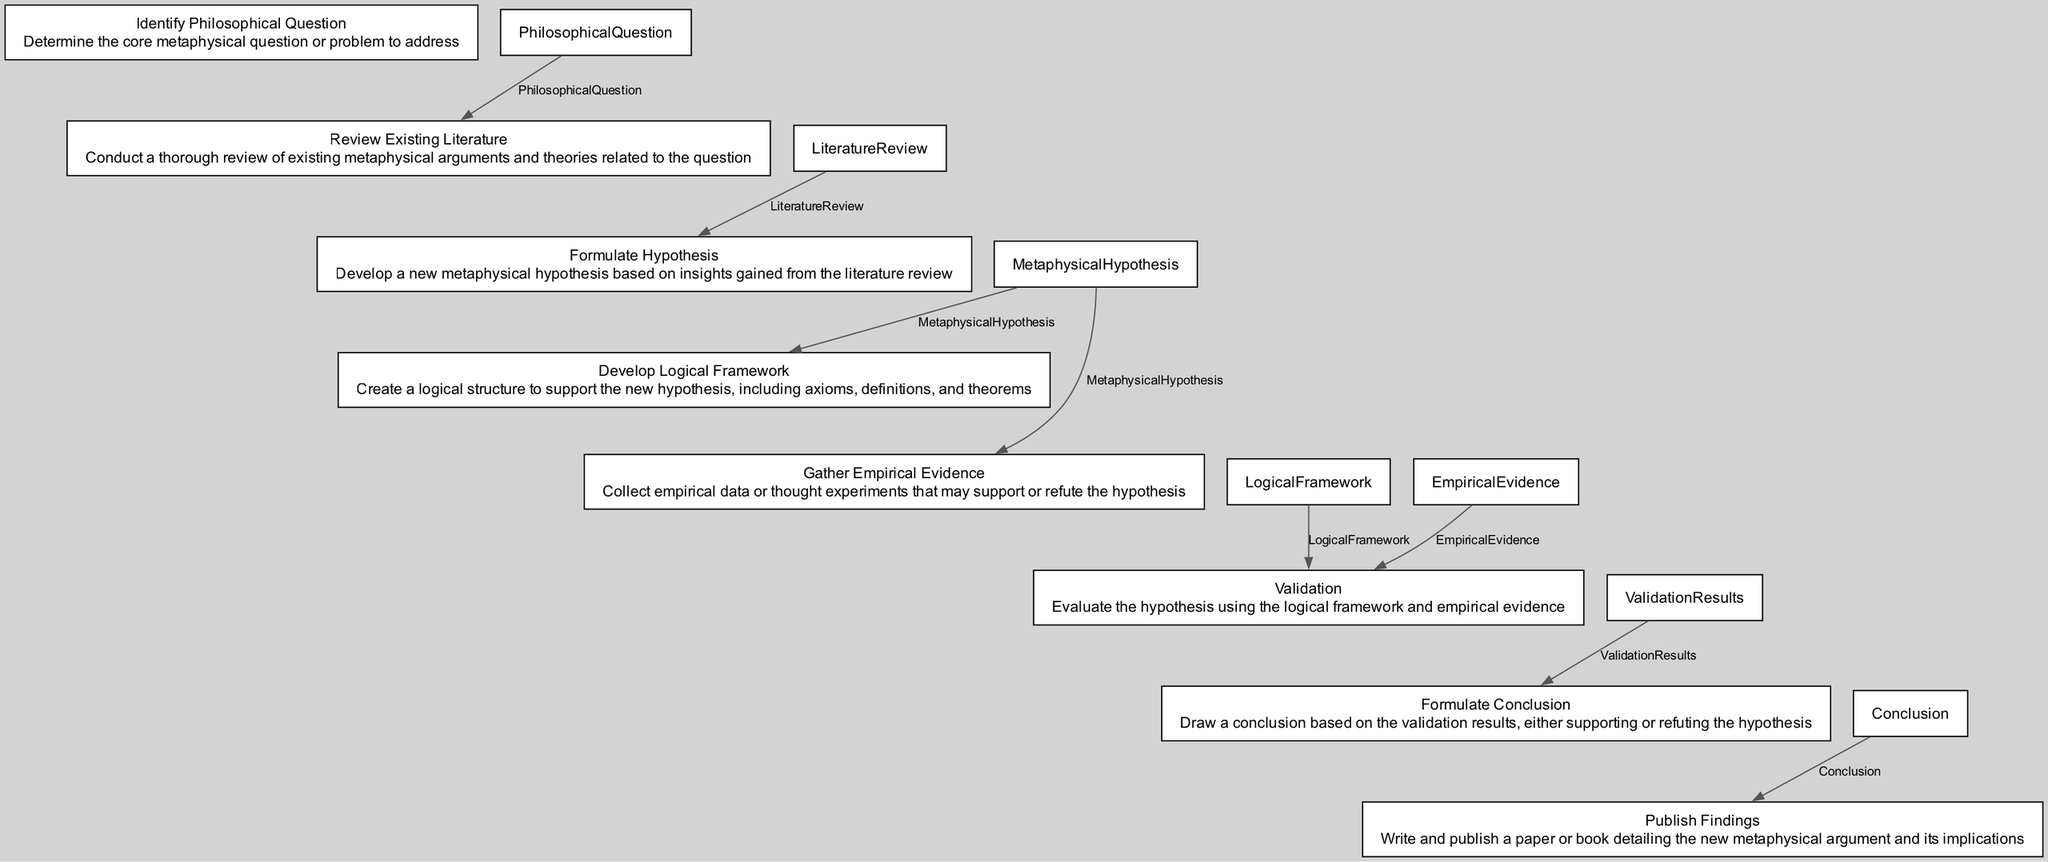What is the first step in the process? The first step in the flowchart is "Identify Philosophical Question," which focuses on determining the core metaphysical question or problem.
Answer: Identify Philosophical Question How many nodes are present in the diagram? The diagram contains eight nodes, representing each step in the process of formulating a new metaphysical argument.
Answer: Eight What does the "Validation" step evaluate? The "Validation" step evaluates the hypothesis using both the logical framework and empirical evidence gathered earlier in the process.
Answer: The hypothesis Which step follows "Gather Empirical Evidence"? The step that follows "Gather Empirical Evidence" is "Validation," where the hypothesis is evaluated against the gathered evidence.
Answer: Validation What is the output of the "Formulate Hypothesis" process? The output of the "Formulate Hypothesis" process is "MetaphysicalHypothesis," which is the new hypothesis developed based on the literature review.
Answer: MetaphysicalHypothesis What is required before publishing findings? Before publishing findings, it is necessary to draw a conclusion based on the validation results, which will either support or refute the hypothesis.
Answer: Conclusion How does "Review Existing Literature" relate to "Identify Philosophical Question"? "Review Existing Literature" is dependent on the output of "Identify Philosophical Question" as it uses the received philosophical question to conduct a literature review.
Answer: Input What type of evidence is gathered in the "Gather Empirical Evidence" step? The evidence gathered in this step can be empirical data or thought experiments that may support or refute the hypothesis being examined.
Answer: Empirical data or thought experiments 